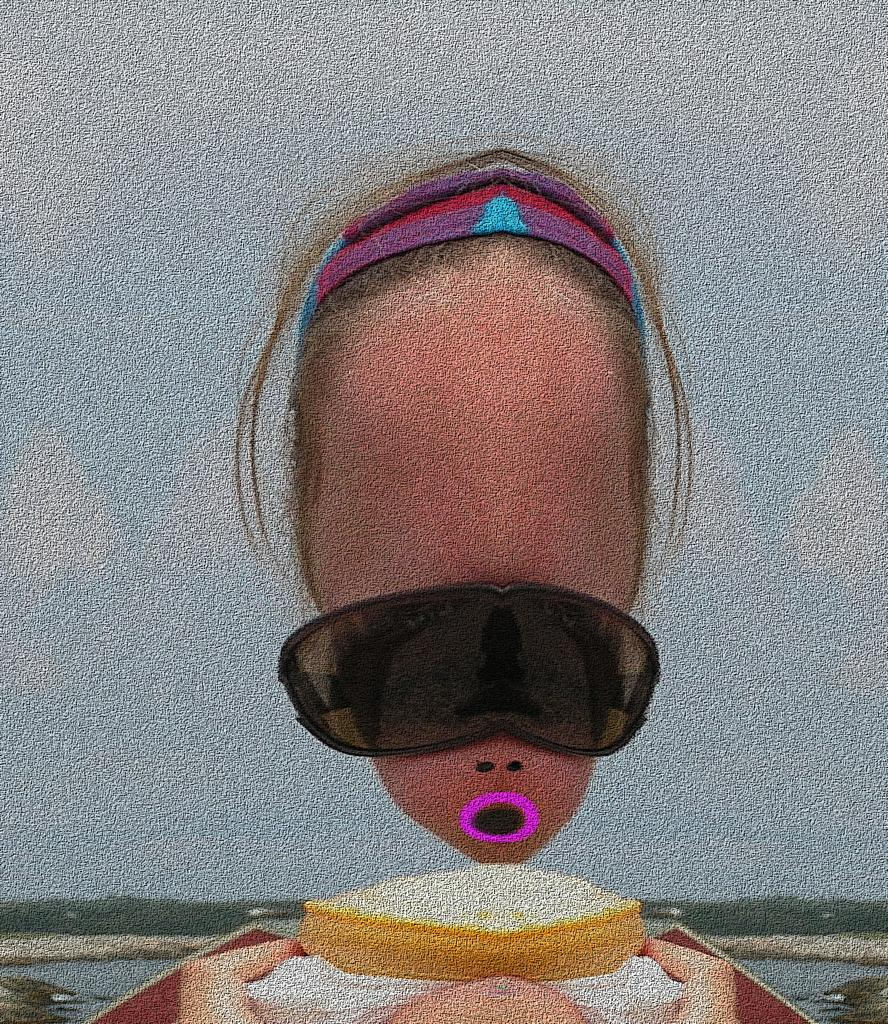What is the person in the image wearing on their face? The person in the image is wearing goggles. What type of natural environment can be seen in the image? There are trees visible in the image, indicating a natural environment. What is visible in the sky in the image? The sky is visible in the image. What type of landscape is present in the image? There is water visible in the image, suggesting a landscape with a body of water. How many chairs are visible in the image? There are no chairs present in the image. What type of hole can be seen in the water in the image? There is no hole visible in the water in the image. 